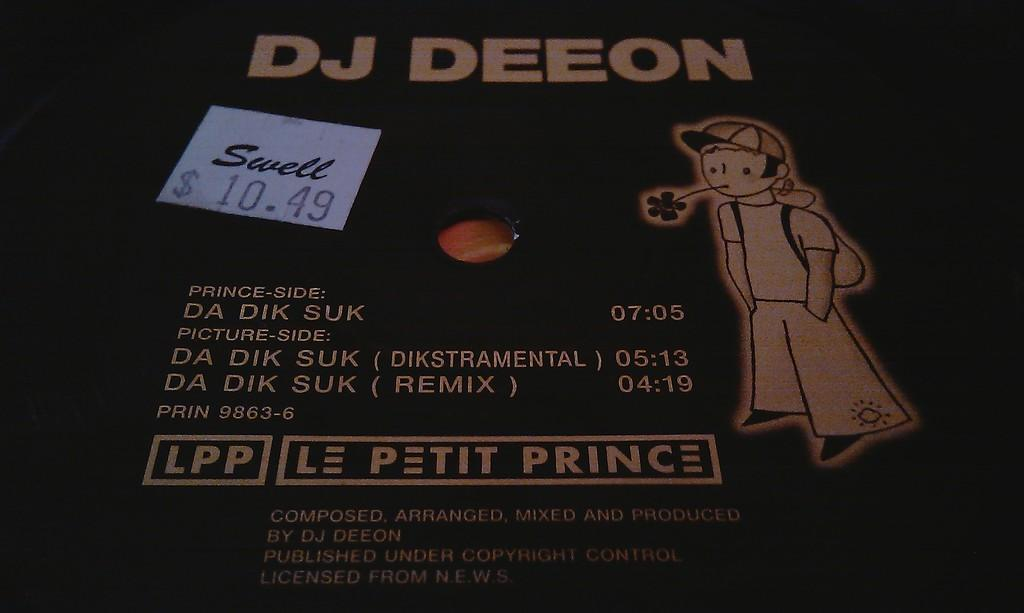What can be found in the image besides the person and the flower? There is text in the image. What is the person doing in the image? The person is placing a flower in their mouth. How would you describe the overall appearance of the image? The background of the image is dark. What type of tent can be seen in the image? There is no tent present in the image. What topic is the person talking about while placing the flower in their mouth? The image does not show the person talking, so it cannot be determined what they might be discussing. 